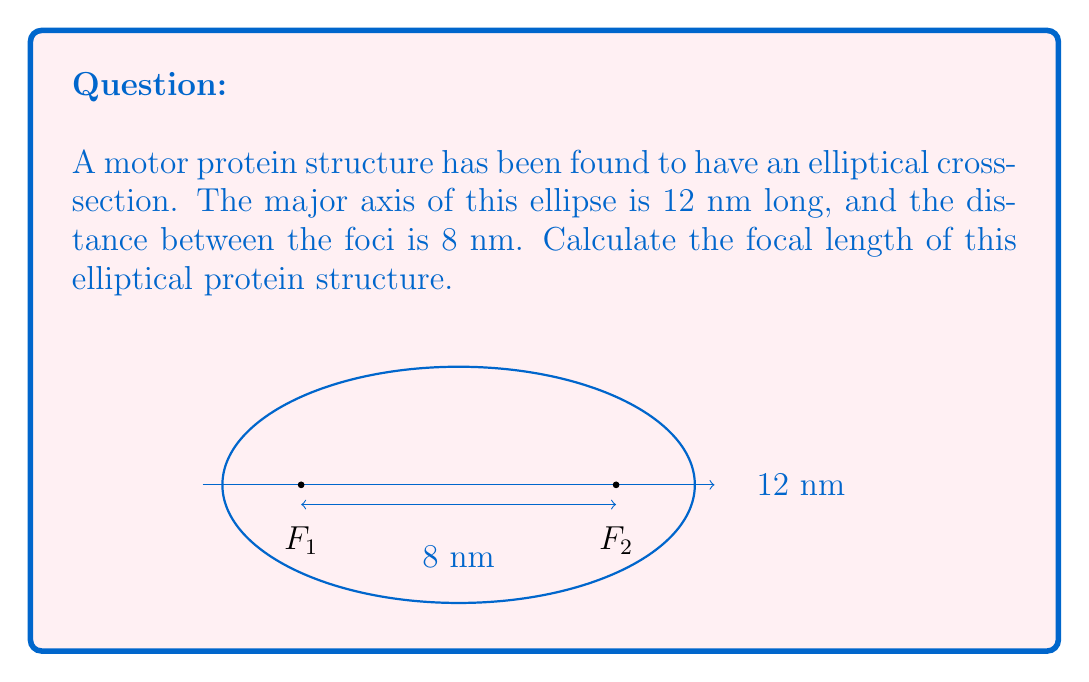Show me your answer to this math problem. Let's approach this step-by-step:

1) In an ellipse, the focal length (c) is half the distance between the foci. Given that the distance between the foci is 8 nm, we can calculate c:

   $c = \frac{8 \text{ nm}}{2} = 4 \text{ nm}$

2) The major axis (2a) is given as 12 nm. We can find a:

   $a = \frac{12 \text{ nm}}{2} = 6 \text{ nm}$

3) In an ellipse, the relationship between a, b (half the minor axis), and c is given by the equation:

   $a^2 = b^2 + c^2$

4) We can rearrange this to find b:

   $b^2 = a^2 - c^2$

5) Substituting the values:

   $b^2 = 6^2 - 4^2 = 36 - 16 = 20$

6) Taking the square root:

   $b = \sqrt{20} = 2\sqrt{5} \text{ nm}$

7) The focal length (f) of an ellipse is given by the equation:

   $f = \frac{a^2}{2c}$

8) Substituting our values:

   $f = \frac{6^2}{2(4)} = \frac{36}{8} = 4.5 \text{ nm}$

Therefore, the focal length of the elliptical protein structure is 4.5 nm.
Answer: $4.5 \text{ nm}$ 